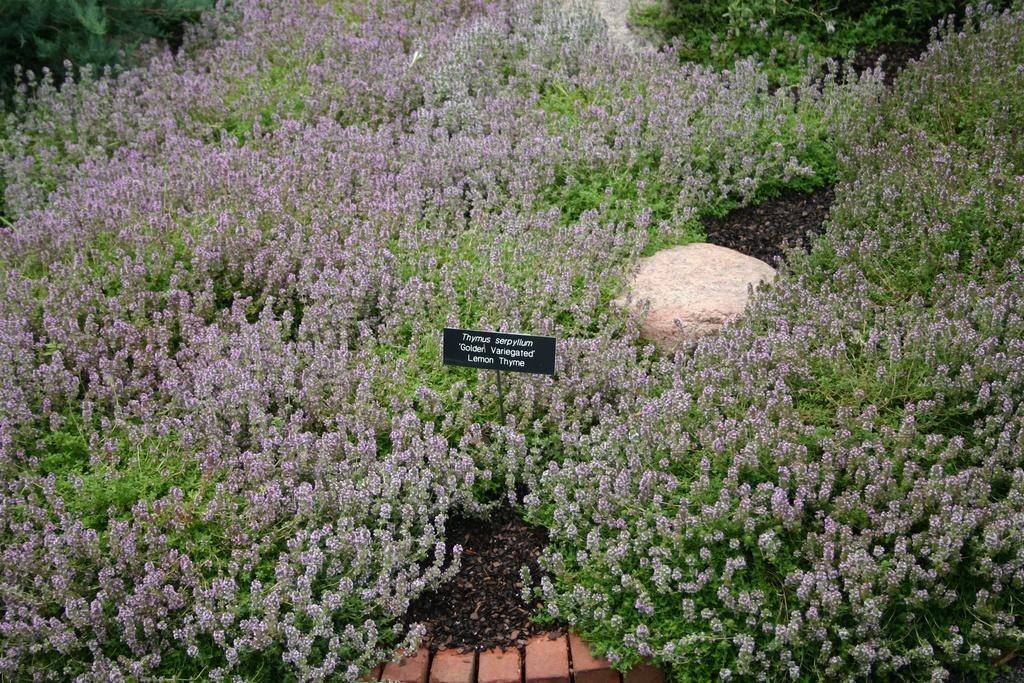What type of living organisms can be seen in the image? There are flowers and plants visible in the image. What material is the stone made of? The stone is made of a solid, non-living material. What can be seen at the bottom of the image? There are bricks visible at the bottom of the image. What type of drug is being sold on the property in the image? There is no indication of any drug or property in the image; it features flowers, plants, a stone, and bricks. Can you see any bats flying around in the image? There are no bats visible in the image. 